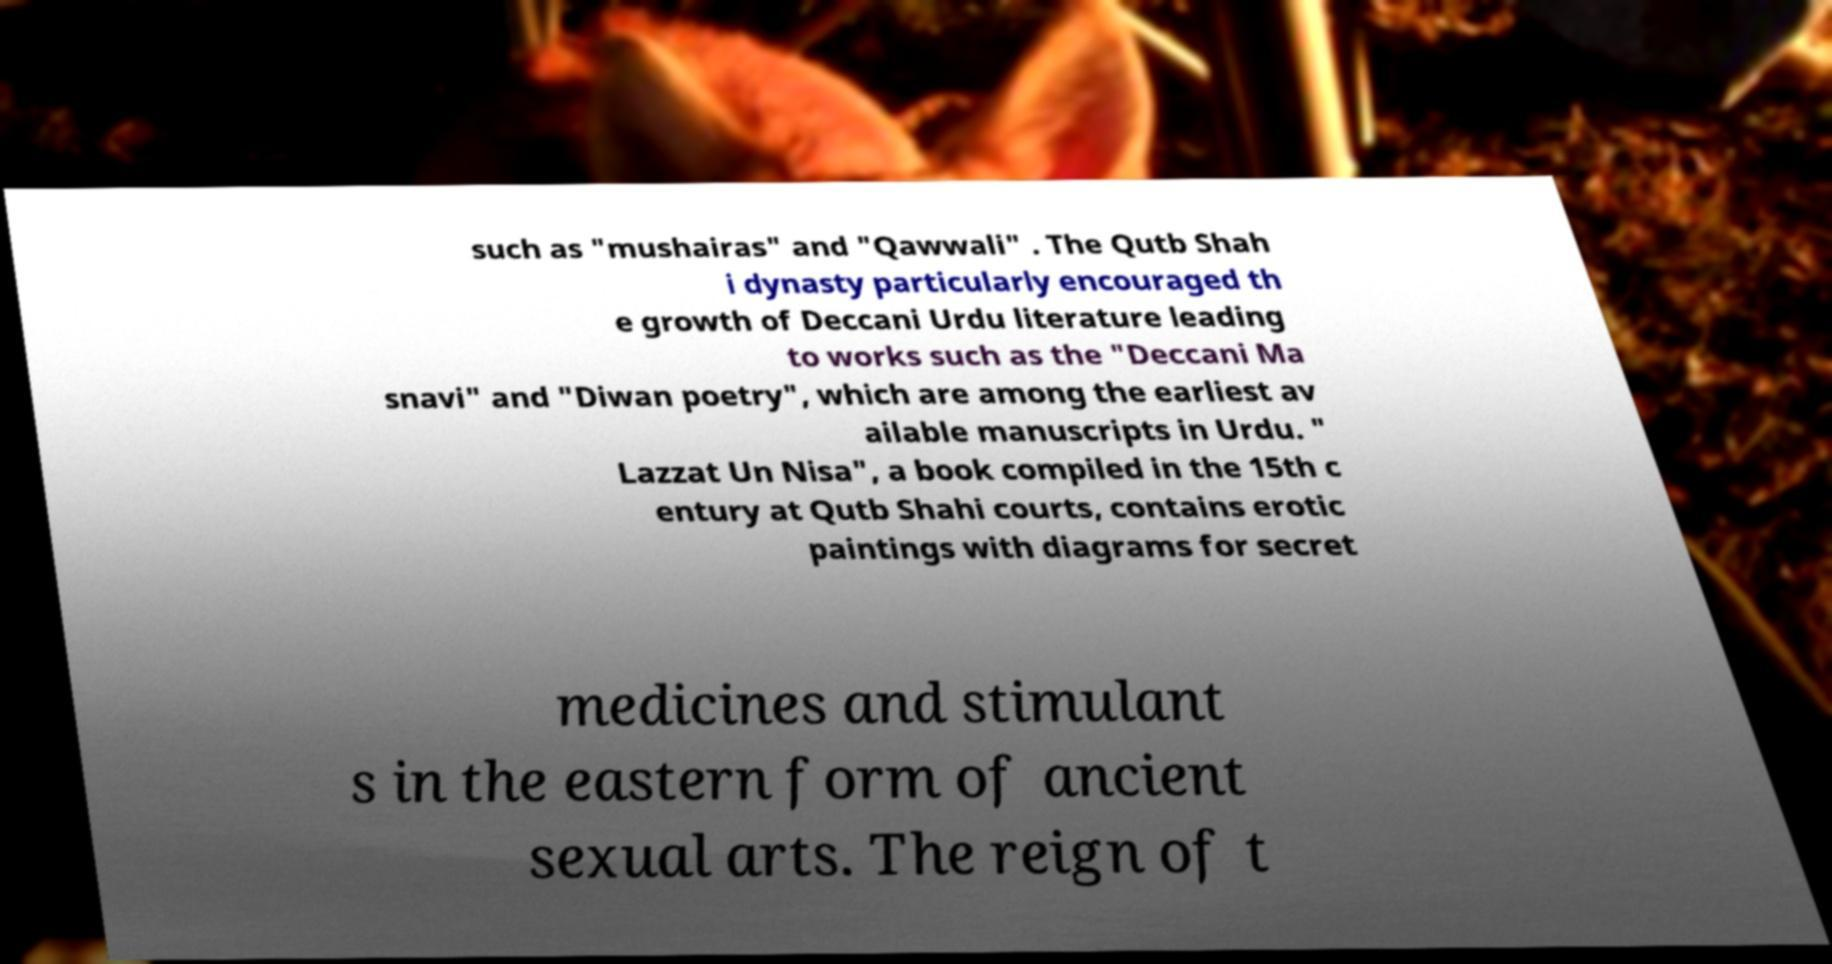Can you read and provide the text displayed in the image?This photo seems to have some interesting text. Can you extract and type it out for me? such as "mushairas" and "Qawwali" . The Qutb Shah i dynasty particularly encouraged th e growth of Deccani Urdu literature leading to works such as the "Deccani Ma snavi" and "Diwan poetry", which are among the earliest av ailable manuscripts in Urdu. " Lazzat Un Nisa", a book compiled in the 15th c entury at Qutb Shahi courts, contains erotic paintings with diagrams for secret medicines and stimulant s in the eastern form of ancient sexual arts. The reign of t 